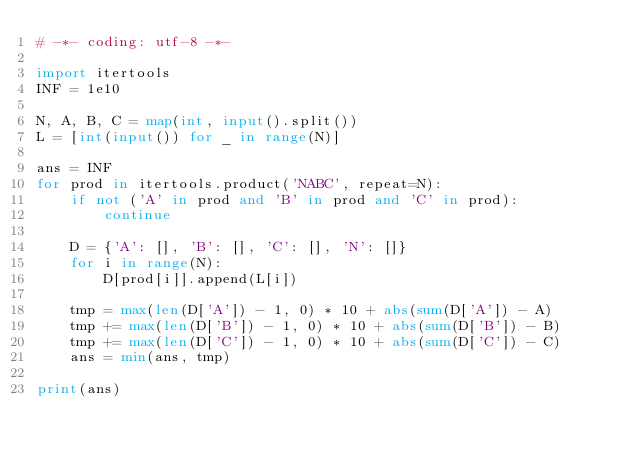<code> <loc_0><loc_0><loc_500><loc_500><_Python_># -*- coding: utf-8 -*-

import itertools
INF = 1e10

N, A, B, C = map(int, input().split())
L = [int(input()) for _ in range(N)]

ans = INF
for prod in itertools.product('NABC', repeat=N):
    if not ('A' in prod and 'B' in prod and 'C' in prod):
        continue

    D = {'A': [], 'B': [], 'C': [], 'N': []}
    for i in range(N):
        D[prod[i]].append(L[i])

    tmp = max(len(D['A']) - 1, 0) * 10 + abs(sum(D['A']) - A)
    tmp += max(len(D['B']) - 1, 0) * 10 + abs(sum(D['B']) - B)
    tmp += max(len(D['C']) - 1, 0) * 10 + abs(sum(D['C']) - C)
    ans = min(ans, tmp)

print(ans)
</code> 